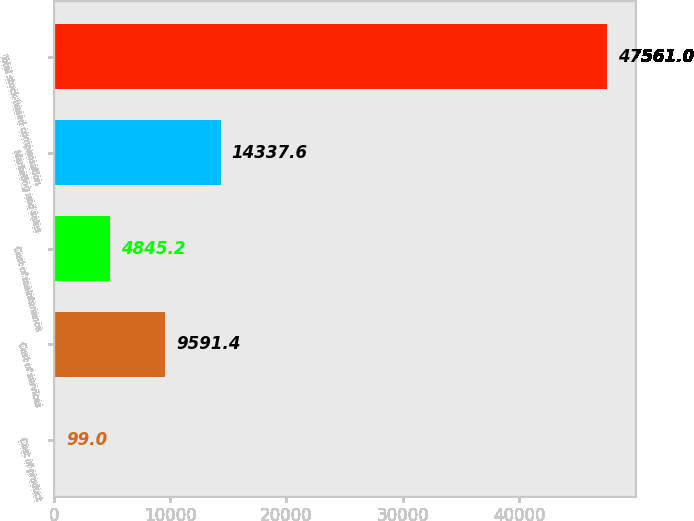Convert chart. <chart><loc_0><loc_0><loc_500><loc_500><bar_chart><fcel>Cost of product<fcel>Cost of services<fcel>Cost of maintenance<fcel>Marketing and sales<fcel>Total stock-based compensation<nl><fcel>99<fcel>9591.4<fcel>4845.2<fcel>14337.6<fcel>47561<nl></chart> 